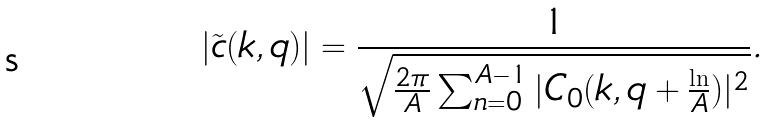<formula> <loc_0><loc_0><loc_500><loc_500>| \tilde { c } ( k , q ) | = \frac { 1 } { \sqrt { \frac { 2 \pi } { A } \sum _ { n = 0 } ^ { A - 1 } | C _ { 0 } ( k , q + \frac { \ln } { A } ) | ^ { 2 } } } .</formula> 